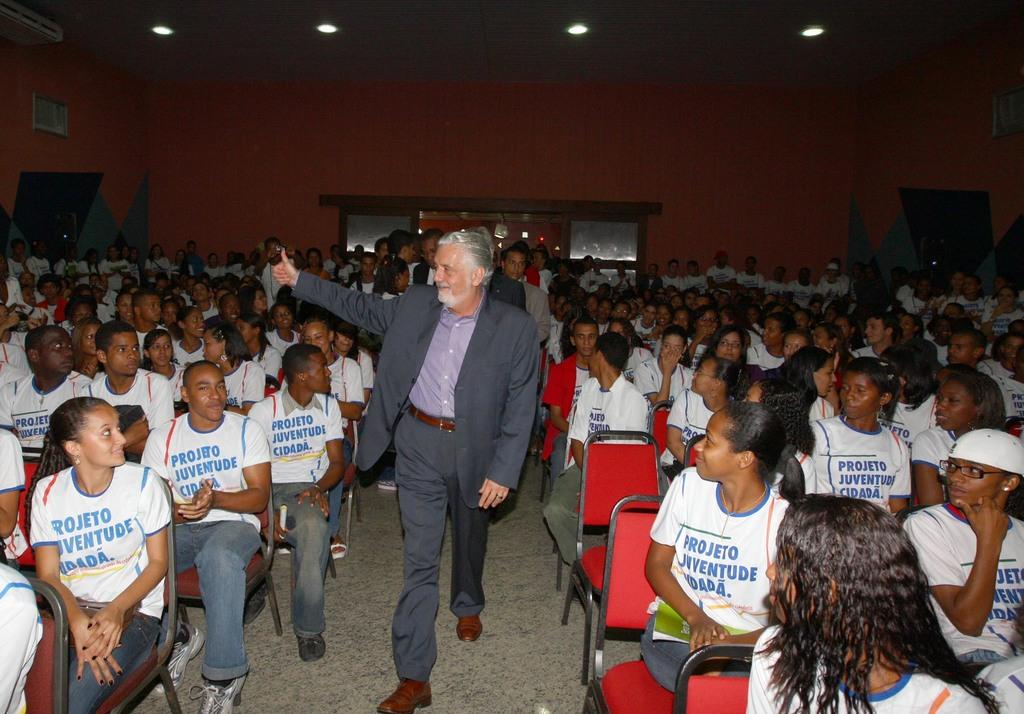What is the main subject of the image? There is a person standing in the middle of the image. What is the person wearing? The person is wearing a blazer. Can you describe the people in the background? There are other persons sitting in the background. What is visible at the top of the image? There is a wall at the top of the image. What type of impulse can be seen affecting the cattle in the image? There are no cattle present in the image, so it is not possible to determine if any impulse is affecting them. 